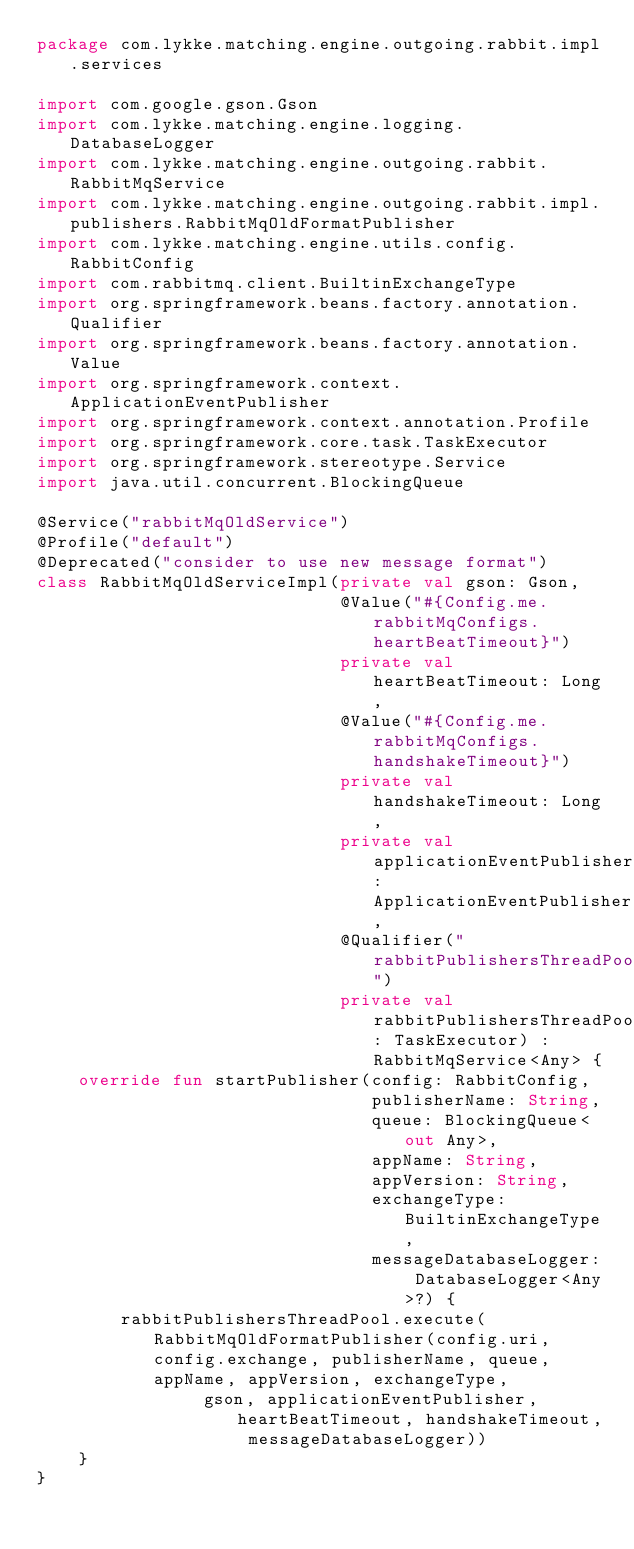<code> <loc_0><loc_0><loc_500><loc_500><_Kotlin_>package com.lykke.matching.engine.outgoing.rabbit.impl.services

import com.google.gson.Gson
import com.lykke.matching.engine.logging.DatabaseLogger
import com.lykke.matching.engine.outgoing.rabbit.RabbitMqService
import com.lykke.matching.engine.outgoing.rabbit.impl.publishers.RabbitMqOldFormatPublisher
import com.lykke.matching.engine.utils.config.RabbitConfig
import com.rabbitmq.client.BuiltinExchangeType
import org.springframework.beans.factory.annotation.Qualifier
import org.springframework.beans.factory.annotation.Value
import org.springframework.context.ApplicationEventPublisher
import org.springframework.context.annotation.Profile
import org.springframework.core.task.TaskExecutor
import org.springframework.stereotype.Service
import java.util.concurrent.BlockingQueue

@Service("rabbitMqOldService")
@Profile("default")
@Deprecated("consider to use new message format")
class RabbitMqOldServiceImpl(private val gson: Gson,
                             @Value("#{Config.me.rabbitMqConfigs.heartBeatTimeout}")
                             private val heartBeatTimeout: Long,
                             @Value("#{Config.me.rabbitMqConfigs.handshakeTimeout}")
                             private val handshakeTimeout: Long,
                             private val applicationEventPublisher: ApplicationEventPublisher,
                             @Qualifier("rabbitPublishersThreadPool")
                             private val rabbitPublishersThreadPool: TaskExecutor) : RabbitMqService<Any> {
    override fun startPublisher(config: RabbitConfig,
                                publisherName: String,
                                queue: BlockingQueue<out Any>,
                                appName: String,
                                appVersion: String,
                                exchangeType: BuiltinExchangeType,
                                messageDatabaseLogger: DatabaseLogger<Any>?) {
        rabbitPublishersThreadPool.execute(RabbitMqOldFormatPublisher(config.uri, config.exchange, publisherName, queue, appName, appVersion, exchangeType,
                gson, applicationEventPublisher, heartBeatTimeout, handshakeTimeout, messageDatabaseLogger))
    }
}</code> 